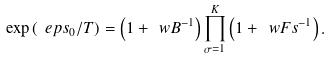<formula> <loc_0><loc_0><loc_500><loc_500>\exp \left ( \ e p s _ { 0 } / T \right ) = \left ( 1 + \ w B ^ { - 1 } \right ) \prod _ { \sigma = 1 } ^ { K } \left ( 1 + \ w F s ^ { - 1 } \right ) .</formula> 